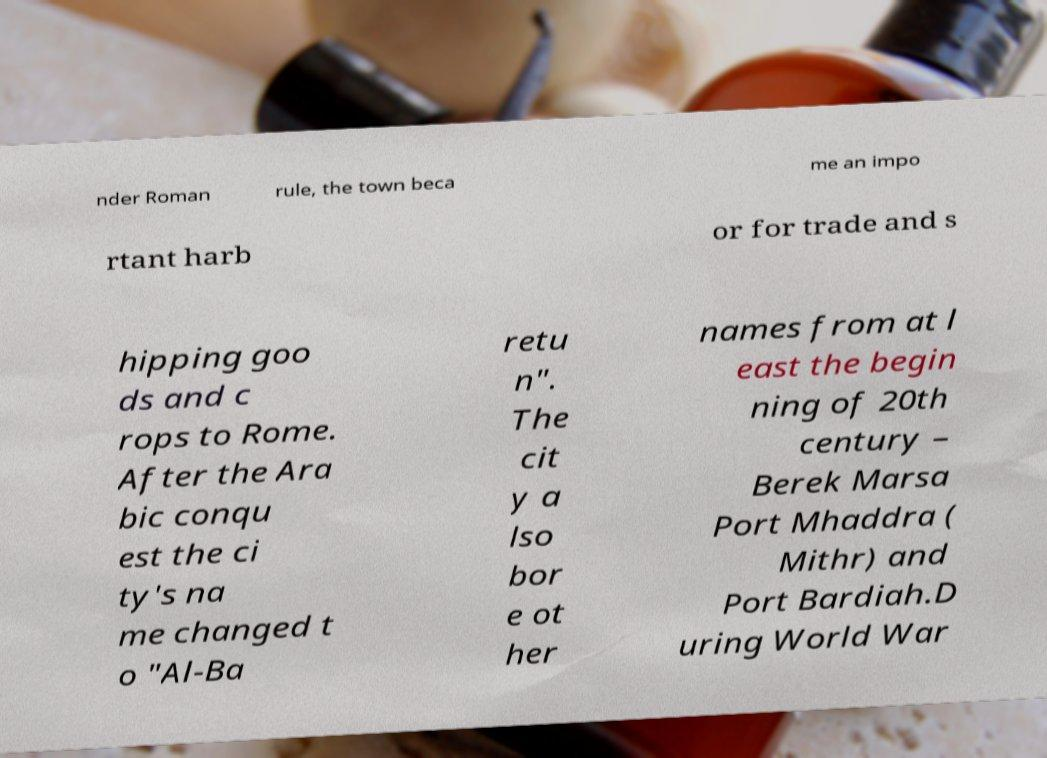What messages or text are displayed in this image? I need them in a readable, typed format. nder Roman rule, the town beca me an impo rtant harb or for trade and s hipping goo ds and c rops to Rome. After the Ara bic conqu est the ci ty's na me changed t o "Al-Ba retu n". The cit y a lso bor e ot her names from at l east the begin ning of 20th century – Berek Marsa Port Mhaddra ( Mithr) and Port Bardiah.D uring World War 